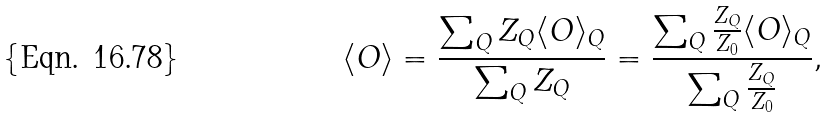<formula> <loc_0><loc_0><loc_500><loc_500>\langle O \rangle = \frac { \sum _ { Q } Z _ { Q } \langle O \rangle _ { Q } } { \sum _ { Q } Z _ { Q } } = \frac { \sum _ { Q } \frac { Z _ { Q } } { Z _ { 0 } } \langle O \rangle _ { Q } } { \sum _ { Q } \frac { Z _ { Q } } { Z _ { 0 } } } ,</formula> 